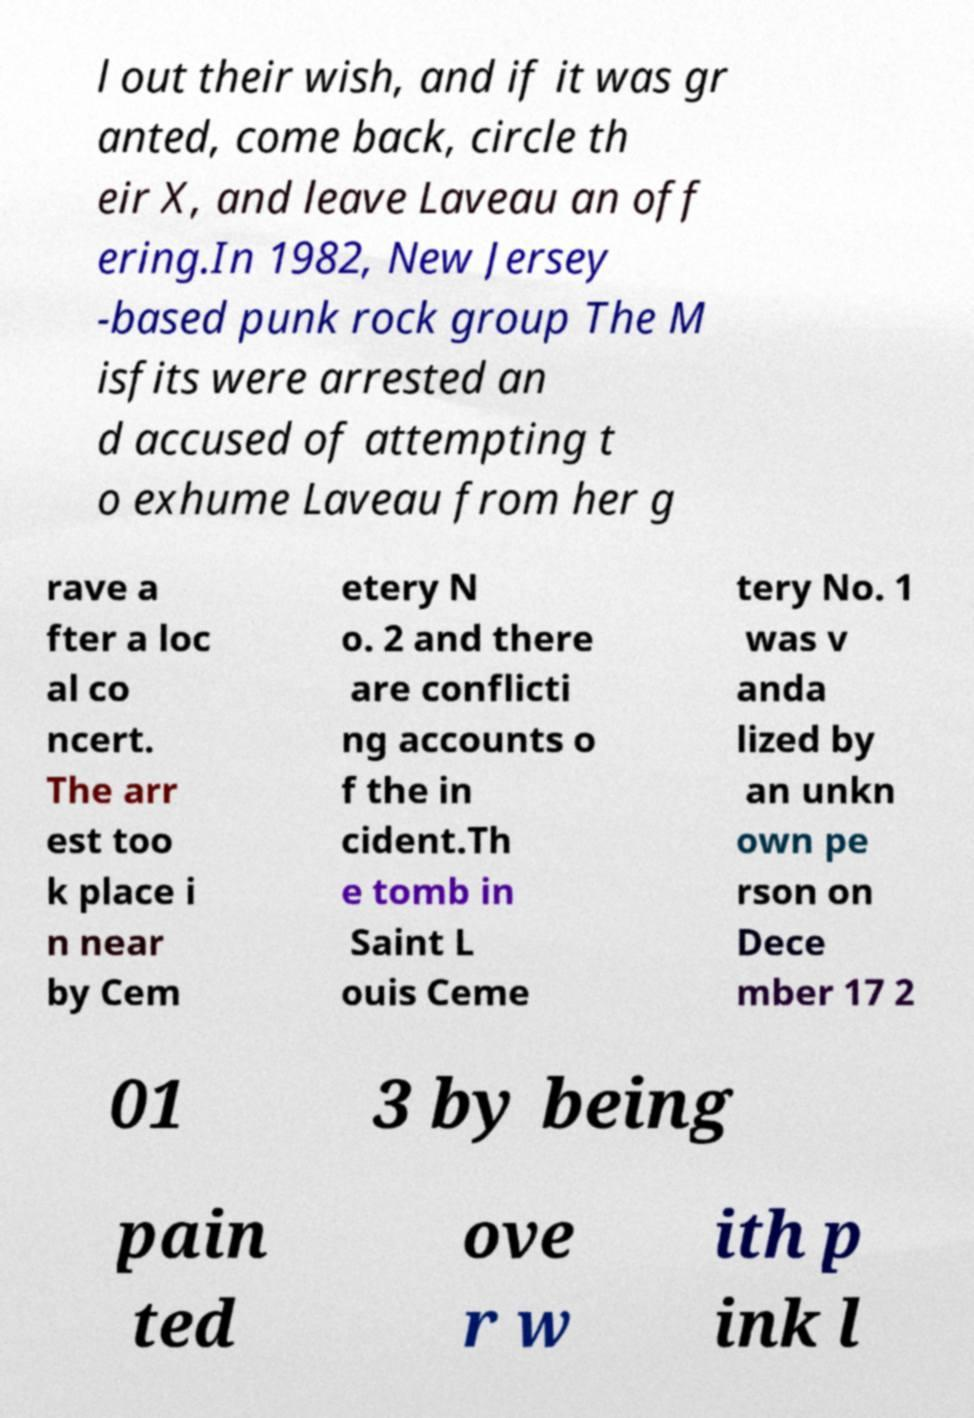Please read and relay the text visible in this image. What does it say? l out their wish, and if it was gr anted, come back, circle th eir X, and leave Laveau an off ering.In 1982, New Jersey -based punk rock group The M isfits were arrested an d accused of attempting t o exhume Laveau from her g rave a fter a loc al co ncert. The arr est too k place i n near by Cem etery N o. 2 and there are conflicti ng accounts o f the in cident.Th e tomb in Saint L ouis Ceme tery No. 1 was v anda lized by an unkn own pe rson on Dece mber 17 2 01 3 by being pain ted ove r w ith p ink l 